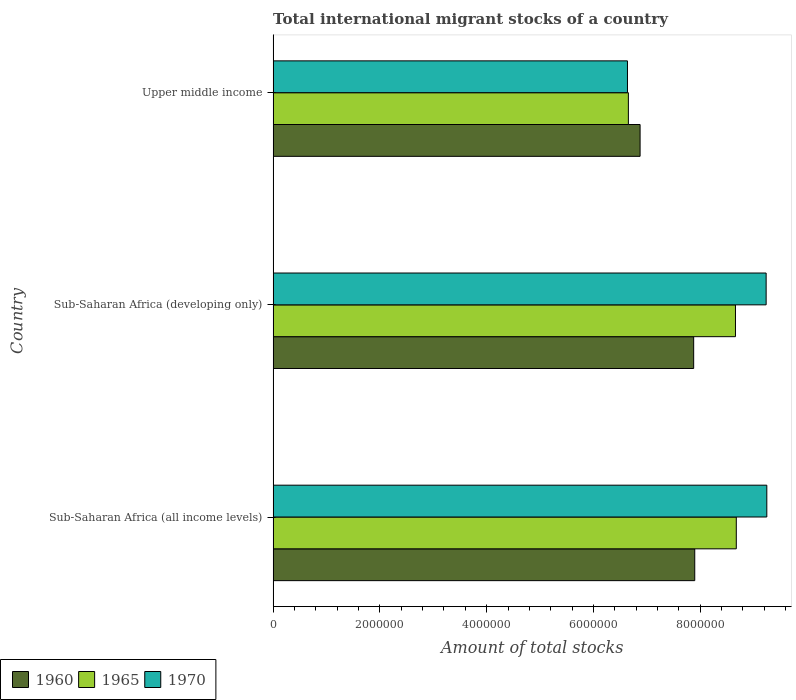How many groups of bars are there?
Offer a terse response. 3. How many bars are there on the 2nd tick from the bottom?
Keep it short and to the point. 3. What is the label of the 3rd group of bars from the top?
Your answer should be very brief. Sub-Saharan Africa (all income levels). In how many cases, is the number of bars for a given country not equal to the number of legend labels?
Give a very brief answer. 0. What is the amount of total stocks in in 1970 in Sub-Saharan Africa (developing only)?
Make the answer very short. 9.23e+06. Across all countries, what is the maximum amount of total stocks in in 1970?
Your answer should be very brief. 9.25e+06. Across all countries, what is the minimum amount of total stocks in in 1965?
Offer a terse response. 6.65e+06. In which country was the amount of total stocks in in 1960 maximum?
Offer a terse response. Sub-Saharan Africa (all income levels). In which country was the amount of total stocks in in 1960 minimum?
Make the answer very short. Upper middle income. What is the total amount of total stocks in in 1965 in the graph?
Make the answer very short. 2.40e+07. What is the difference between the amount of total stocks in in 1970 in Sub-Saharan Africa (developing only) and that in Upper middle income?
Offer a terse response. 2.60e+06. What is the difference between the amount of total stocks in in 1960 in Upper middle income and the amount of total stocks in in 1970 in Sub-Saharan Africa (all income levels)?
Keep it short and to the point. -2.37e+06. What is the average amount of total stocks in in 1970 per country?
Keep it short and to the point. 8.37e+06. What is the difference between the amount of total stocks in in 1970 and amount of total stocks in in 1965 in Sub-Saharan Africa (all income levels)?
Offer a very short reply. 5.72e+05. What is the ratio of the amount of total stocks in in 1970 in Sub-Saharan Africa (developing only) to that in Upper middle income?
Offer a terse response. 1.39. Is the difference between the amount of total stocks in in 1970 in Sub-Saharan Africa (all income levels) and Sub-Saharan Africa (developing only) greater than the difference between the amount of total stocks in in 1965 in Sub-Saharan Africa (all income levels) and Sub-Saharan Africa (developing only)?
Your answer should be compact. No. What is the difference between the highest and the second highest amount of total stocks in in 1960?
Your answer should be very brief. 2.02e+04. What is the difference between the highest and the lowest amount of total stocks in in 1965?
Make the answer very short. 2.02e+06. What does the 2nd bar from the bottom in Sub-Saharan Africa (all income levels) represents?
Offer a terse response. 1965. How many bars are there?
Provide a succinct answer. 9. How many countries are there in the graph?
Your answer should be compact. 3. Does the graph contain any zero values?
Your answer should be compact. No. Does the graph contain grids?
Provide a succinct answer. No. Where does the legend appear in the graph?
Ensure brevity in your answer.  Bottom left. What is the title of the graph?
Provide a short and direct response. Total international migrant stocks of a country. What is the label or title of the X-axis?
Offer a very short reply. Amount of total stocks. What is the label or title of the Y-axis?
Your answer should be compact. Country. What is the Amount of total stocks in 1960 in Sub-Saharan Africa (all income levels)?
Keep it short and to the point. 7.90e+06. What is the Amount of total stocks in 1965 in Sub-Saharan Africa (all income levels)?
Offer a terse response. 8.68e+06. What is the Amount of total stocks in 1970 in Sub-Saharan Africa (all income levels)?
Make the answer very short. 9.25e+06. What is the Amount of total stocks in 1960 in Sub-Saharan Africa (developing only)?
Provide a succinct answer. 7.88e+06. What is the Amount of total stocks in 1965 in Sub-Saharan Africa (developing only)?
Your answer should be very brief. 8.66e+06. What is the Amount of total stocks of 1970 in Sub-Saharan Africa (developing only)?
Make the answer very short. 9.23e+06. What is the Amount of total stocks in 1960 in Upper middle income?
Ensure brevity in your answer.  6.87e+06. What is the Amount of total stocks of 1965 in Upper middle income?
Make the answer very short. 6.65e+06. What is the Amount of total stocks in 1970 in Upper middle income?
Your answer should be very brief. 6.64e+06. Across all countries, what is the maximum Amount of total stocks of 1960?
Offer a terse response. 7.90e+06. Across all countries, what is the maximum Amount of total stocks in 1965?
Your answer should be compact. 8.68e+06. Across all countries, what is the maximum Amount of total stocks in 1970?
Ensure brevity in your answer.  9.25e+06. Across all countries, what is the minimum Amount of total stocks of 1960?
Provide a succinct answer. 6.87e+06. Across all countries, what is the minimum Amount of total stocks of 1965?
Ensure brevity in your answer.  6.65e+06. Across all countries, what is the minimum Amount of total stocks in 1970?
Your response must be concise. 6.64e+06. What is the total Amount of total stocks of 1960 in the graph?
Provide a succinct answer. 2.26e+07. What is the total Amount of total stocks of 1965 in the graph?
Make the answer very short. 2.40e+07. What is the total Amount of total stocks in 1970 in the graph?
Your response must be concise. 2.51e+07. What is the difference between the Amount of total stocks in 1960 in Sub-Saharan Africa (all income levels) and that in Sub-Saharan Africa (developing only)?
Keep it short and to the point. 2.02e+04. What is the difference between the Amount of total stocks in 1965 in Sub-Saharan Africa (all income levels) and that in Sub-Saharan Africa (developing only)?
Your response must be concise. 1.54e+04. What is the difference between the Amount of total stocks of 1970 in Sub-Saharan Africa (all income levels) and that in Sub-Saharan Africa (developing only)?
Ensure brevity in your answer.  1.26e+04. What is the difference between the Amount of total stocks of 1960 in Sub-Saharan Africa (all income levels) and that in Upper middle income?
Ensure brevity in your answer.  1.02e+06. What is the difference between the Amount of total stocks of 1965 in Sub-Saharan Africa (all income levels) and that in Upper middle income?
Give a very brief answer. 2.02e+06. What is the difference between the Amount of total stocks in 1970 in Sub-Saharan Africa (all income levels) and that in Upper middle income?
Give a very brief answer. 2.61e+06. What is the difference between the Amount of total stocks in 1960 in Sub-Saharan Africa (developing only) and that in Upper middle income?
Offer a terse response. 1.00e+06. What is the difference between the Amount of total stocks of 1965 in Sub-Saharan Africa (developing only) and that in Upper middle income?
Your answer should be very brief. 2.01e+06. What is the difference between the Amount of total stocks in 1970 in Sub-Saharan Africa (developing only) and that in Upper middle income?
Your answer should be compact. 2.60e+06. What is the difference between the Amount of total stocks in 1960 in Sub-Saharan Africa (all income levels) and the Amount of total stocks in 1965 in Sub-Saharan Africa (developing only)?
Make the answer very short. -7.63e+05. What is the difference between the Amount of total stocks in 1960 in Sub-Saharan Africa (all income levels) and the Amount of total stocks in 1970 in Sub-Saharan Africa (developing only)?
Keep it short and to the point. -1.34e+06. What is the difference between the Amount of total stocks in 1965 in Sub-Saharan Africa (all income levels) and the Amount of total stocks in 1970 in Sub-Saharan Africa (developing only)?
Your response must be concise. -5.59e+05. What is the difference between the Amount of total stocks in 1960 in Sub-Saharan Africa (all income levels) and the Amount of total stocks in 1965 in Upper middle income?
Offer a terse response. 1.24e+06. What is the difference between the Amount of total stocks of 1960 in Sub-Saharan Africa (all income levels) and the Amount of total stocks of 1970 in Upper middle income?
Your response must be concise. 1.26e+06. What is the difference between the Amount of total stocks in 1965 in Sub-Saharan Africa (all income levels) and the Amount of total stocks in 1970 in Upper middle income?
Provide a short and direct response. 2.04e+06. What is the difference between the Amount of total stocks in 1960 in Sub-Saharan Africa (developing only) and the Amount of total stocks in 1965 in Upper middle income?
Give a very brief answer. 1.22e+06. What is the difference between the Amount of total stocks of 1960 in Sub-Saharan Africa (developing only) and the Amount of total stocks of 1970 in Upper middle income?
Ensure brevity in your answer.  1.24e+06. What is the difference between the Amount of total stocks of 1965 in Sub-Saharan Africa (developing only) and the Amount of total stocks of 1970 in Upper middle income?
Make the answer very short. 2.02e+06. What is the average Amount of total stocks in 1960 per country?
Your answer should be very brief. 7.55e+06. What is the average Amount of total stocks of 1965 per country?
Make the answer very short. 8.00e+06. What is the average Amount of total stocks in 1970 per country?
Keep it short and to the point. 8.37e+06. What is the difference between the Amount of total stocks in 1960 and Amount of total stocks in 1965 in Sub-Saharan Africa (all income levels)?
Ensure brevity in your answer.  -7.78e+05. What is the difference between the Amount of total stocks of 1960 and Amount of total stocks of 1970 in Sub-Saharan Africa (all income levels)?
Keep it short and to the point. -1.35e+06. What is the difference between the Amount of total stocks of 1965 and Amount of total stocks of 1970 in Sub-Saharan Africa (all income levels)?
Offer a very short reply. -5.72e+05. What is the difference between the Amount of total stocks of 1960 and Amount of total stocks of 1965 in Sub-Saharan Africa (developing only)?
Your answer should be compact. -7.83e+05. What is the difference between the Amount of total stocks of 1960 and Amount of total stocks of 1970 in Sub-Saharan Africa (developing only)?
Your answer should be very brief. -1.36e+06. What is the difference between the Amount of total stocks in 1965 and Amount of total stocks in 1970 in Sub-Saharan Africa (developing only)?
Provide a succinct answer. -5.74e+05. What is the difference between the Amount of total stocks of 1960 and Amount of total stocks of 1965 in Upper middle income?
Offer a very short reply. 2.19e+05. What is the difference between the Amount of total stocks in 1960 and Amount of total stocks in 1970 in Upper middle income?
Provide a succinct answer. 2.36e+05. What is the difference between the Amount of total stocks in 1965 and Amount of total stocks in 1970 in Upper middle income?
Offer a terse response. 1.70e+04. What is the ratio of the Amount of total stocks in 1960 in Sub-Saharan Africa (all income levels) to that in Sub-Saharan Africa (developing only)?
Ensure brevity in your answer.  1. What is the ratio of the Amount of total stocks of 1970 in Sub-Saharan Africa (all income levels) to that in Sub-Saharan Africa (developing only)?
Your answer should be compact. 1. What is the ratio of the Amount of total stocks of 1960 in Sub-Saharan Africa (all income levels) to that in Upper middle income?
Make the answer very short. 1.15. What is the ratio of the Amount of total stocks of 1965 in Sub-Saharan Africa (all income levels) to that in Upper middle income?
Offer a very short reply. 1.3. What is the ratio of the Amount of total stocks in 1970 in Sub-Saharan Africa (all income levels) to that in Upper middle income?
Offer a terse response. 1.39. What is the ratio of the Amount of total stocks of 1960 in Sub-Saharan Africa (developing only) to that in Upper middle income?
Offer a terse response. 1.15. What is the ratio of the Amount of total stocks of 1965 in Sub-Saharan Africa (developing only) to that in Upper middle income?
Ensure brevity in your answer.  1.3. What is the ratio of the Amount of total stocks in 1970 in Sub-Saharan Africa (developing only) to that in Upper middle income?
Keep it short and to the point. 1.39. What is the difference between the highest and the second highest Amount of total stocks in 1960?
Your answer should be very brief. 2.02e+04. What is the difference between the highest and the second highest Amount of total stocks in 1965?
Keep it short and to the point. 1.54e+04. What is the difference between the highest and the second highest Amount of total stocks in 1970?
Provide a short and direct response. 1.26e+04. What is the difference between the highest and the lowest Amount of total stocks in 1960?
Ensure brevity in your answer.  1.02e+06. What is the difference between the highest and the lowest Amount of total stocks in 1965?
Your answer should be compact. 2.02e+06. What is the difference between the highest and the lowest Amount of total stocks in 1970?
Provide a succinct answer. 2.61e+06. 